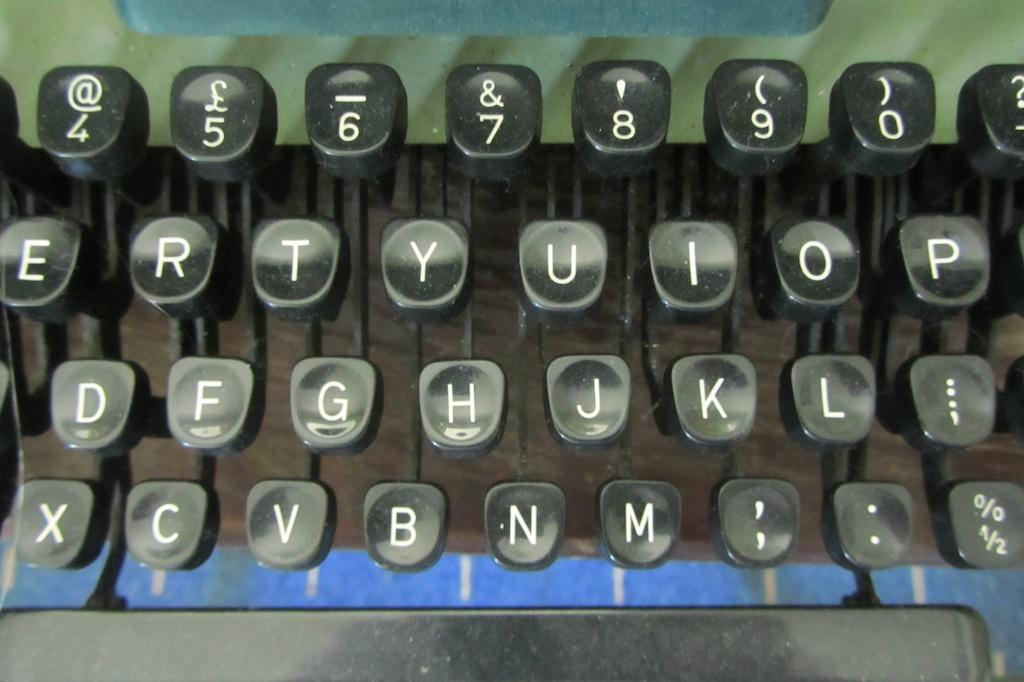<image>
Create a compact narrative representing the image presented. Old typewriter with the letter G in between the letter F and H. 